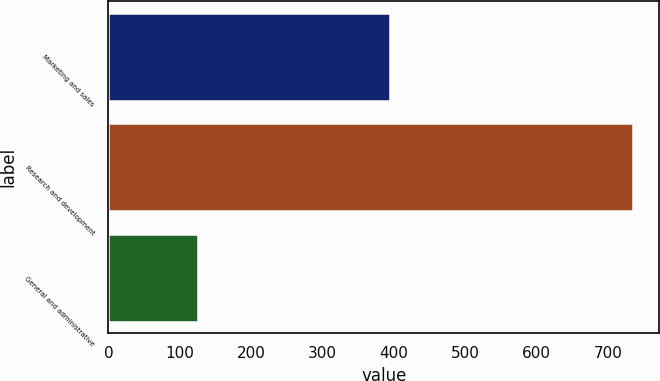Convert chart. <chart><loc_0><loc_0><loc_500><loc_500><bar_chart><fcel>Marketing and sales<fcel>Research and development<fcel>General and administrative<nl><fcel>395.2<fcel>735.3<fcel>125.1<nl></chart> 